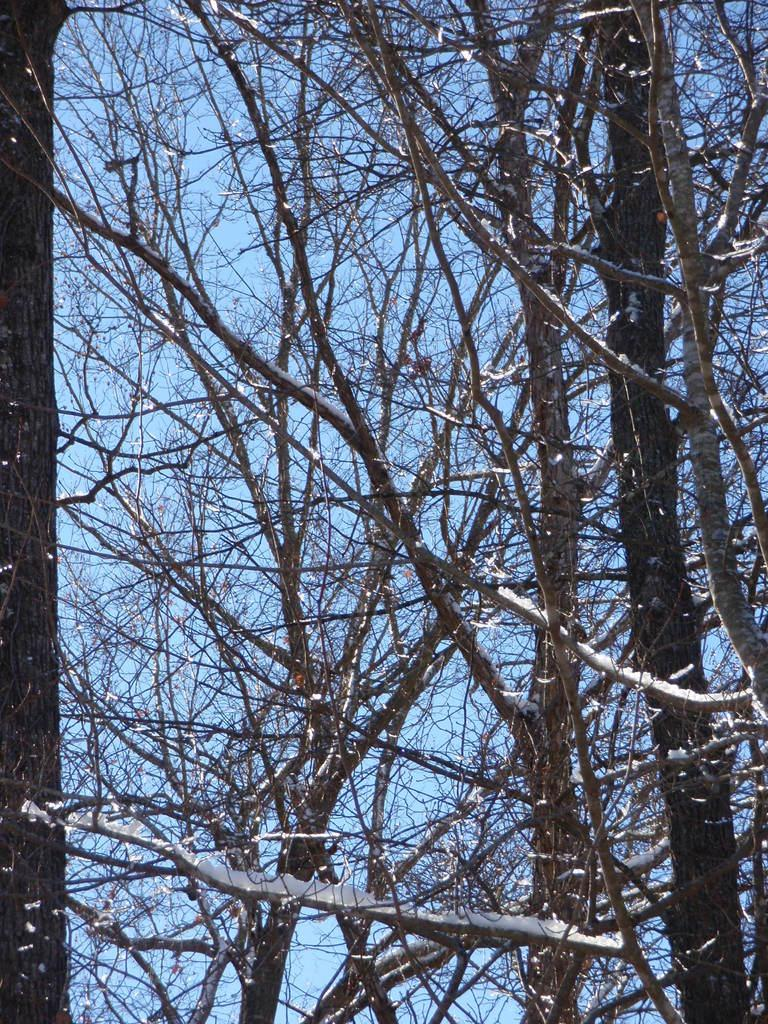What type of vegetation can be seen in the image? There are trees in the image. Can you describe the trees in the image? The provided facts do not include specific details about the trees, so we cannot describe them further. What type of shock can be seen coming from the trees in the image? There is no shock present in the image; it features trees. What type of plate is being offered by the trees in the image? There is no plate or offering present in the image; it features trees. 